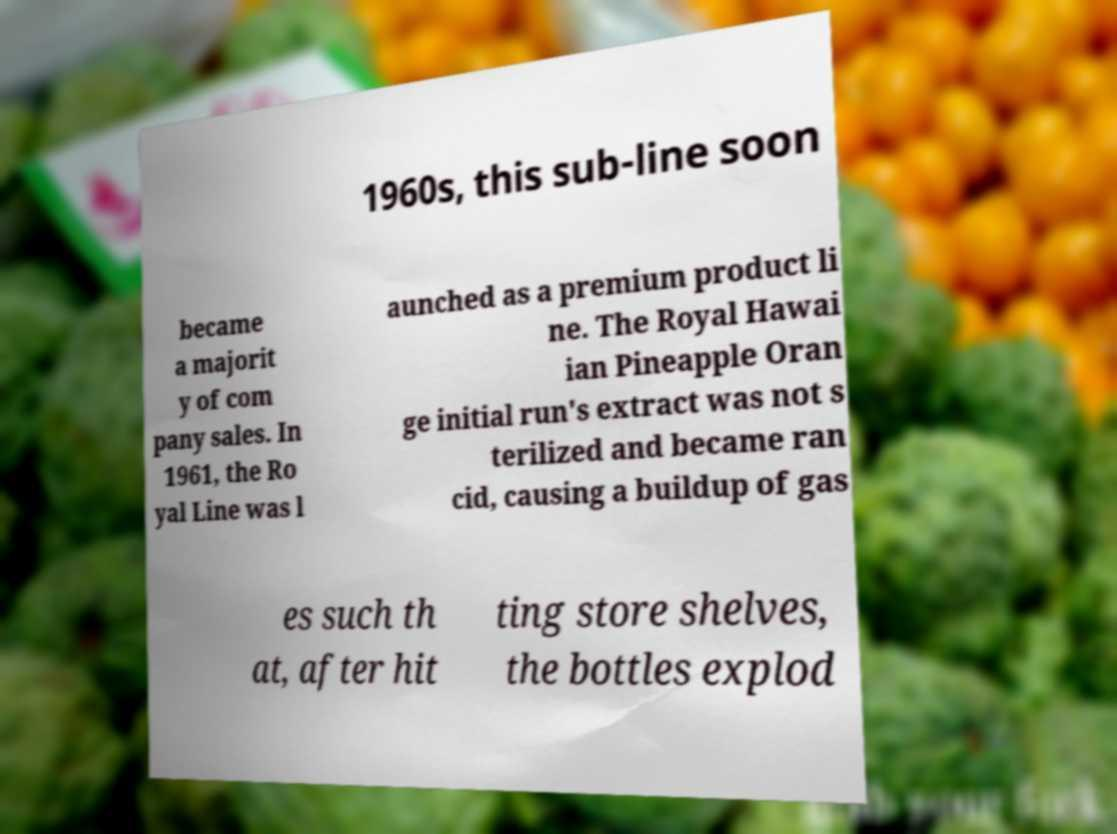Could you assist in decoding the text presented in this image and type it out clearly? 1960s, this sub-line soon became a majorit y of com pany sales. In 1961, the Ro yal Line was l aunched as a premium product li ne. The Royal Hawai ian Pineapple Oran ge initial run's extract was not s terilized and became ran cid, causing a buildup of gas es such th at, after hit ting store shelves, the bottles explod 